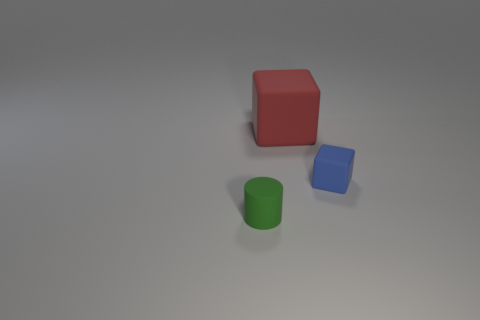Add 1 blue rubber blocks. How many objects exist? 4 Subtract all cylinders. How many objects are left? 2 Add 3 tiny matte things. How many tiny matte things are left? 5 Add 3 blue cubes. How many blue cubes exist? 4 Subtract 0 purple cubes. How many objects are left? 3 Subtract all yellow metal cylinders. Subtract all green cylinders. How many objects are left? 2 